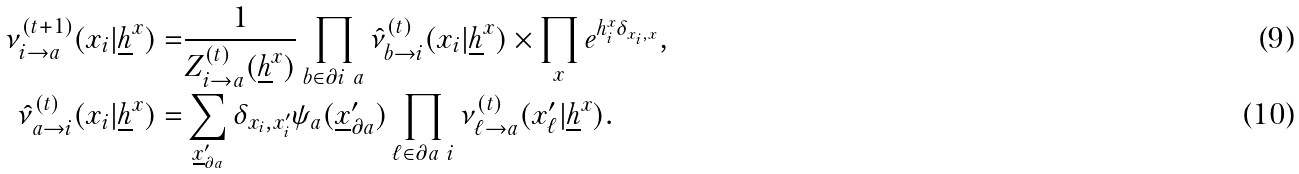<formula> <loc_0><loc_0><loc_500><loc_500>\nu _ { i \rightarrow a } ^ { ( t + 1 ) } ( x _ { i } | \underline { h } ^ { x } ) = & \frac { 1 } { Z ^ { ( t ) } _ { i \rightarrow a } ( \underline { h } ^ { x } ) } \prod _ { b \in \partial i \ a } \hat { \nu } _ { b \rightarrow i } ^ { ( t ) } ( x _ { i } | \underline { h } ^ { x } ) \times \prod _ { x } e ^ { h _ { i } ^ { x } \delta _ { x _ { i } , x } } , \\ \hat { \nu } _ { a \rightarrow i } ^ { ( t ) } ( x _ { i } | \underline { h } ^ { x } ) = & \sum _ { \underline { x } ^ { \prime } _ { \partial a } } \delta _ { x _ { i } , x ^ { \prime } _ { i } } \psi _ { a } ( \underline { x } ^ { \prime } _ { \partial a } ) \prod _ { \ell \in \partial a \ i } \nu _ { \ell \rightarrow a } ^ { ( t ) } ( x ^ { \prime } _ { \ell } | \underline { h } ^ { x } ) .</formula> 